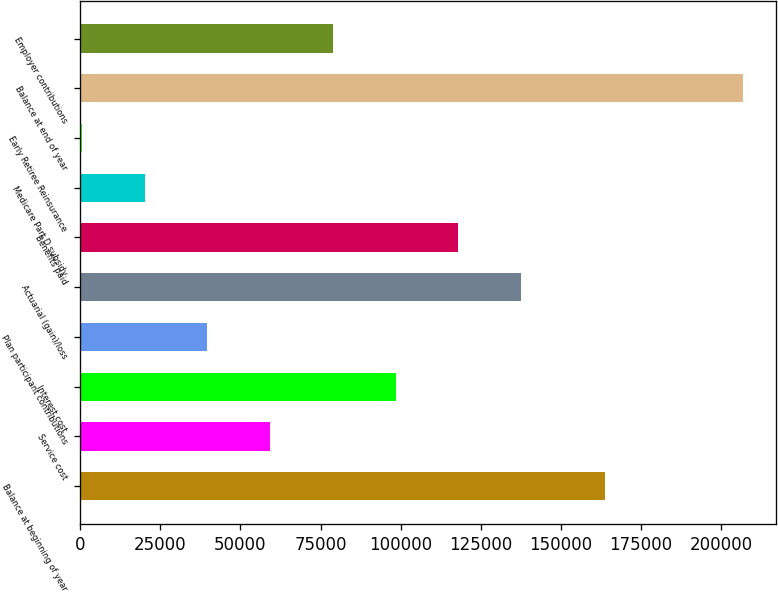<chart> <loc_0><loc_0><loc_500><loc_500><bar_chart><fcel>Balance at beginning of year<fcel>Service cost<fcel>Interest cost<fcel>Plan participant contributions<fcel>Actuarial (gain)/loss<fcel>Benefits paid<fcel>Medicare Part D subsidy<fcel>Early Retiree Reinsurance<fcel>Balance at end of year<fcel>Employer contributions<nl><fcel>163720<fcel>59234.6<fcel>98411<fcel>39646.4<fcel>137587<fcel>117999<fcel>20058.2<fcel>470<fcel>206797<fcel>78822.8<nl></chart> 